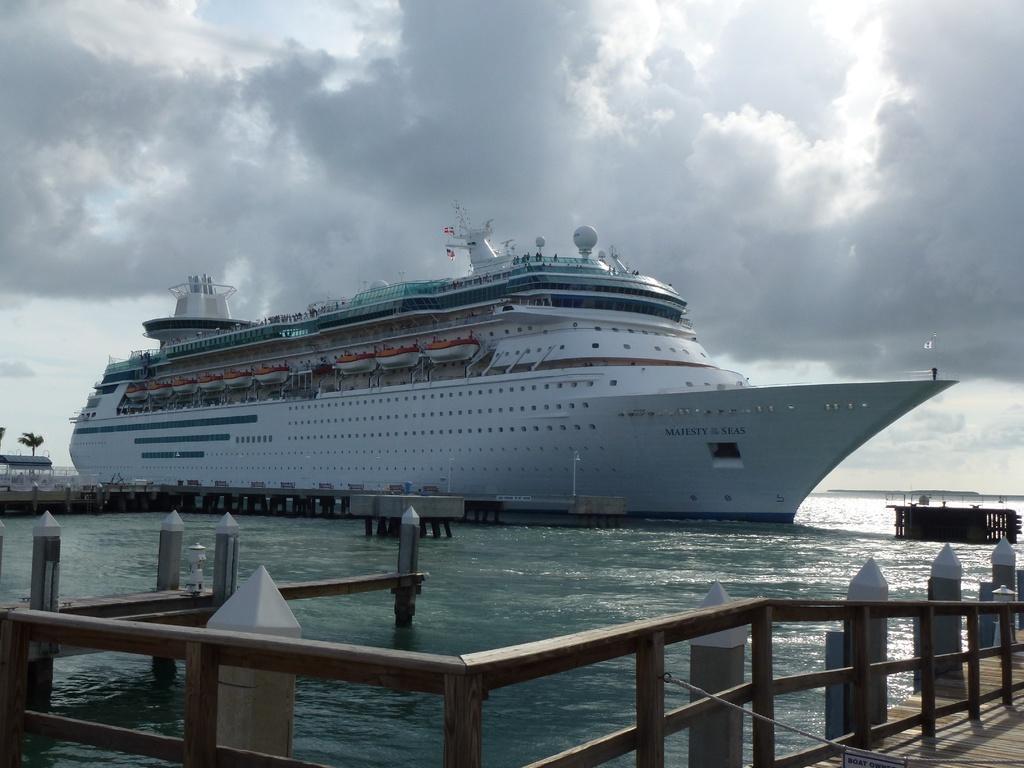Please provide a concise description of this image. In this picture we can see white cruise ship in the seawater. In the front there is a wooden railing and on the top there is a sky and clouds. 